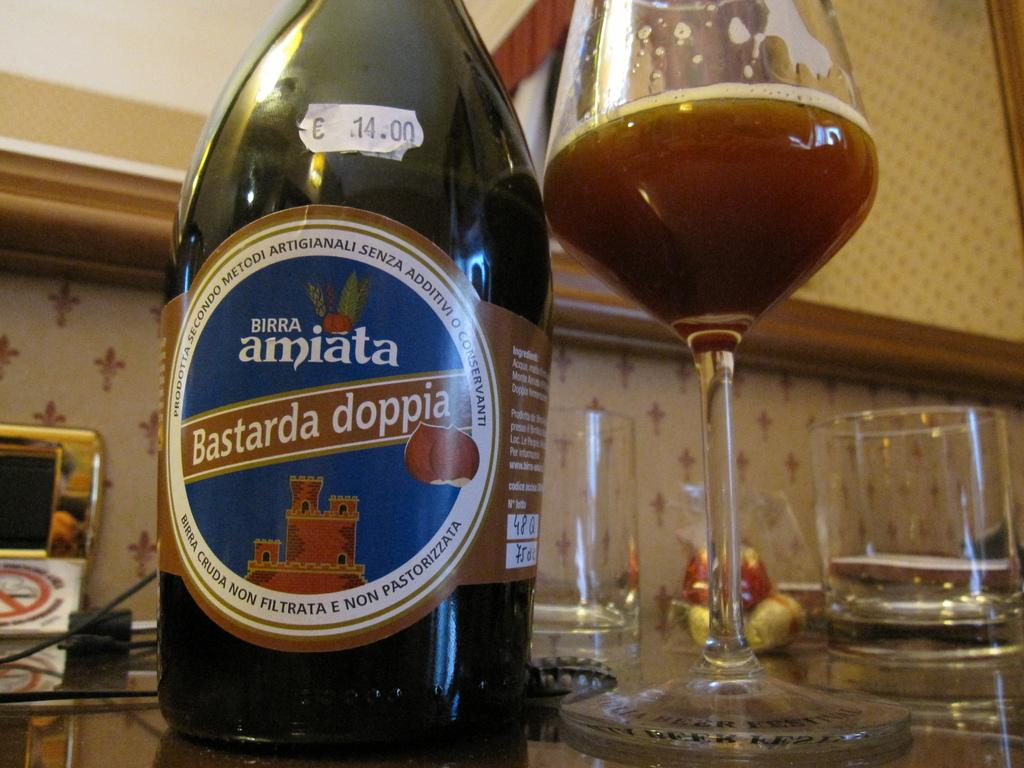What can be seen on the surface in the image? There is a group of objects on a surface in the image. What is visible behind the objects? There is a wall visible behind the objects. Can you describe any additional features on the wall? There is a wooden frame attached to the wall. What type of music is being played by the objects in the image? There is no indication of music being played in the image, as the objects are not musical instruments or devices. What type of vest is hanging on the wooden frame in the image? There is no vest present in the image; only the wooden frame is visible on the wall. 